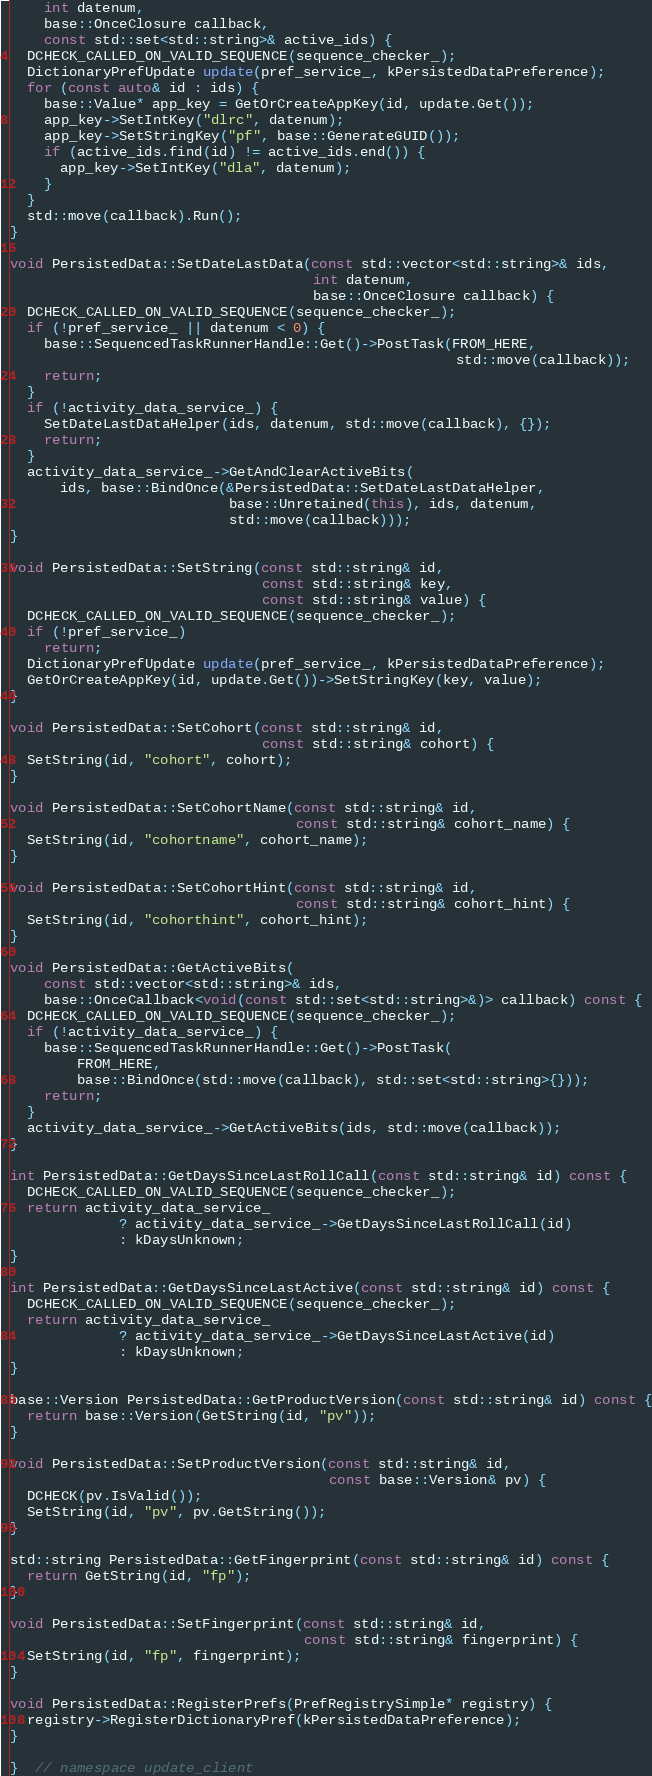Convert code to text. <code><loc_0><loc_0><loc_500><loc_500><_C++_>    int datenum,
    base::OnceClosure callback,
    const std::set<std::string>& active_ids) {
  DCHECK_CALLED_ON_VALID_SEQUENCE(sequence_checker_);
  DictionaryPrefUpdate update(pref_service_, kPersistedDataPreference);
  for (const auto& id : ids) {
    base::Value* app_key = GetOrCreateAppKey(id, update.Get());
    app_key->SetIntKey("dlrc", datenum);
    app_key->SetStringKey("pf", base::GenerateGUID());
    if (active_ids.find(id) != active_ids.end()) {
      app_key->SetIntKey("dla", datenum);
    }
  }
  std::move(callback).Run();
}

void PersistedData::SetDateLastData(const std::vector<std::string>& ids,
                                    int datenum,
                                    base::OnceClosure callback) {
  DCHECK_CALLED_ON_VALID_SEQUENCE(sequence_checker_);
  if (!pref_service_ || datenum < 0) {
    base::SequencedTaskRunnerHandle::Get()->PostTask(FROM_HERE,
                                                     std::move(callback));
    return;
  }
  if (!activity_data_service_) {
    SetDateLastDataHelper(ids, datenum, std::move(callback), {});
    return;
  }
  activity_data_service_->GetAndClearActiveBits(
      ids, base::BindOnce(&PersistedData::SetDateLastDataHelper,
                          base::Unretained(this), ids, datenum,
                          std::move(callback)));
}

void PersistedData::SetString(const std::string& id,
                              const std::string& key,
                              const std::string& value) {
  DCHECK_CALLED_ON_VALID_SEQUENCE(sequence_checker_);
  if (!pref_service_)
    return;
  DictionaryPrefUpdate update(pref_service_, kPersistedDataPreference);
  GetOrCreateAppKey(id, update.Get())->SetStringKey(key, value);
}

void PersistedData::SetCohort(const std::string& id,
                              const std::string& cohort) {
  SetString(id, "cohort", cohort);
}

void PersistedData::SetCohortName(const std::string& id,
                                  const std::string& cohort_name) {
  SetString(id, "cohortname", cohort_name);
}

void PersistedData::SetCohortHint(const std::string& id,
                                  const std::string& cohort_hint) {
  SetString(id, "cohorthint", cohort_hint);
}

void PersistedData::GetActiveBits(
    const std::vector<std::string>& ids,
    base::OnceCallback<void(const std::set<std::string>&)> callback) const {
  DCHECK_CALLED_ON_VALID_SEQUENCE(sequence_checker_);
  if (!activity_data_service_) {
    base::SequencedTaskRunnerHandle::Get()->PostTask(
        FROM_HERE,
        base::BindOnce(std::move(callback), std::set<std::string>{}));
    return;
  }
  activity_data_service_->GetActiveBits(ids, std::move(callback));
}

int PersistedData::GetDaysSinceLastRollCall(const std::string& id) const {
  DCHECK_CALLED_ON_VALID_SEQUENCE(sequence_checker_);
  return activity_data_service_
             ? activity_data_service_->GetDaysSinceLastRollCall(id)
             : kDaysUnknown;
}

int PersistedData::GetDaysSinceLastActive(const std::string& id) const {
  DCHECK_CALLED_ON_VALID_SEQUENCE(sequence_checker_);
  return activity_data_service_
             ? activity_data_service_->GetDaysSinceLastActive(id)
             : kDaysUnknown;
}

base::Version PersistedData::GetProductVersion(const std::string& id) const {
  return base::Version(GetString(id, "pv"));
}

void PersistedData::SetProductVersion(const std::string& id,
                                      const base::Version& pv) {
  DCHECK(pv.IsValid());
  SetString(id, "pv", pv.GetString());
}

std::string PersistedData::GetFingerprint(const std::string& id) const {
  return GetString(id, "fp");
}

void PersistedData::SetFingerprint(const std::string& id,
                                   const std::string& fingerprint) {
  SetString(id, "fp", fingerprint);
}

void PersistedData::RegisterPrefs(PrefRegistrySimple* registry) {
  registry->RegisterDictionaryPref(kPersistedDataPreference);
}

}  // namespace update_client
</code> 